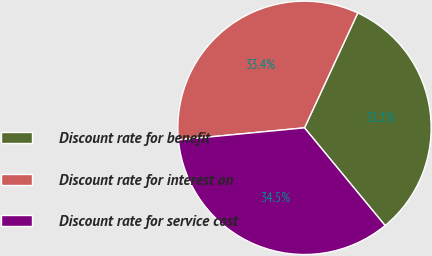Convert chart to OTSL. <chart><loc_0><loc_0><loc_500><loc_500><pie_chart><fcel>Discount rate for benefit<fcel>Discount rate for interest on<fcel>Discount rate for service cost<nl><fcel>32.11%<fcel>33.43%<fcel>34.46%<nl></chart> 